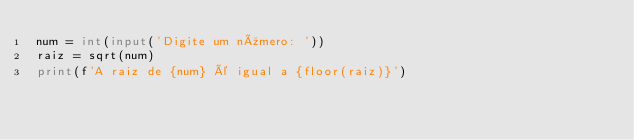<code> <loc_0><loc_0><loc_500><loc_500><_Python_>num = int(input('Digite um número: '))
raiz = sqrt(num)
print(f'A raiz de {num} é igual a {floor(raiz)}')
</code> 